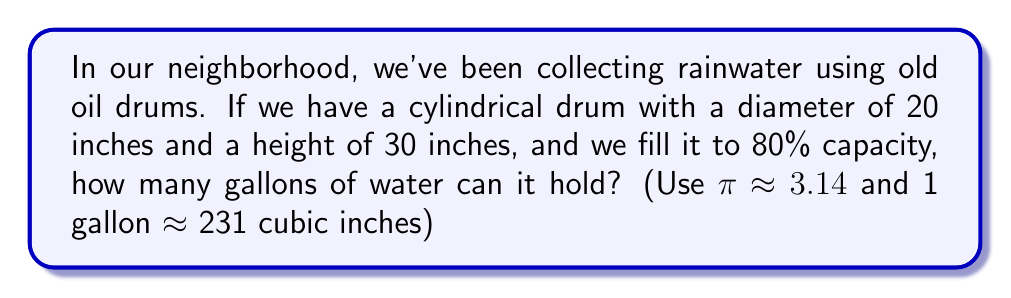What is the answer to this math problem? Let's approach this step-by-step:

1) First, we need to calculate the volume of the entire cylinder:
   $$V = \pi r^2 h$$
   where $r$ is the radius and $h$ is the height.

2) The diameter is 20 inches, so the radius is 10 inches:
   $$V = 3.14 \cdot 10^2 \cdot 30 = 3.14 \cdot 100 \cdot 30 = 9,420 \text{ cubic inches}$$

3) But we're only filling it to 80% capacity, so we need to calculate 80% of this volume:
   $$9,420 \cdot 0.80 = 7,536 \text{ cubic inches}$$

4) Now we need to convert cubic inches to gallons. We're given that 1 gallon ≈ 231 cubic inches:
   $$\frac{7,536 \text{ cubic inches}}{231 \text{ cubic inches/gallon}} \approx 32.62 \text{ gallons}$$

5) Rounding to the nearest gallon (since we're dealing with a makeshift container), we get 33 gallons.
Answer: 33 gallons 